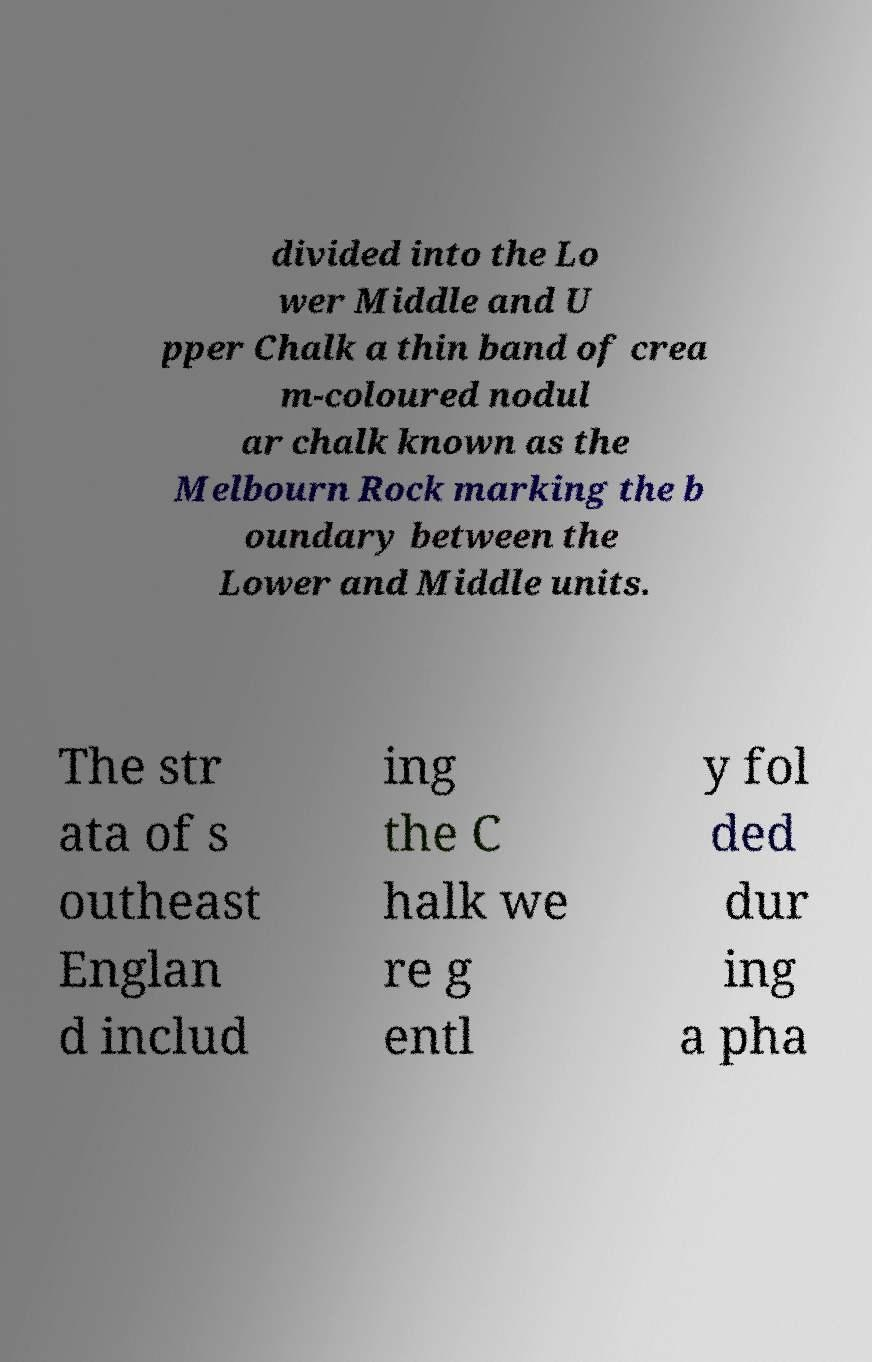Can you read and provide the text displayed in the image?This photo seems to have some interesting text. Can you extract and type it out for me? divided into the Lo wer Middle and U pper Chalk a thin band of crea m-coloured nodul ar chalk known as the Melbourn Rock marking the b oundary between the Lower and Middle units. The str ata of s outheast Englan d includ ing the C halk we re g entl y fol ded dur ing a pha 